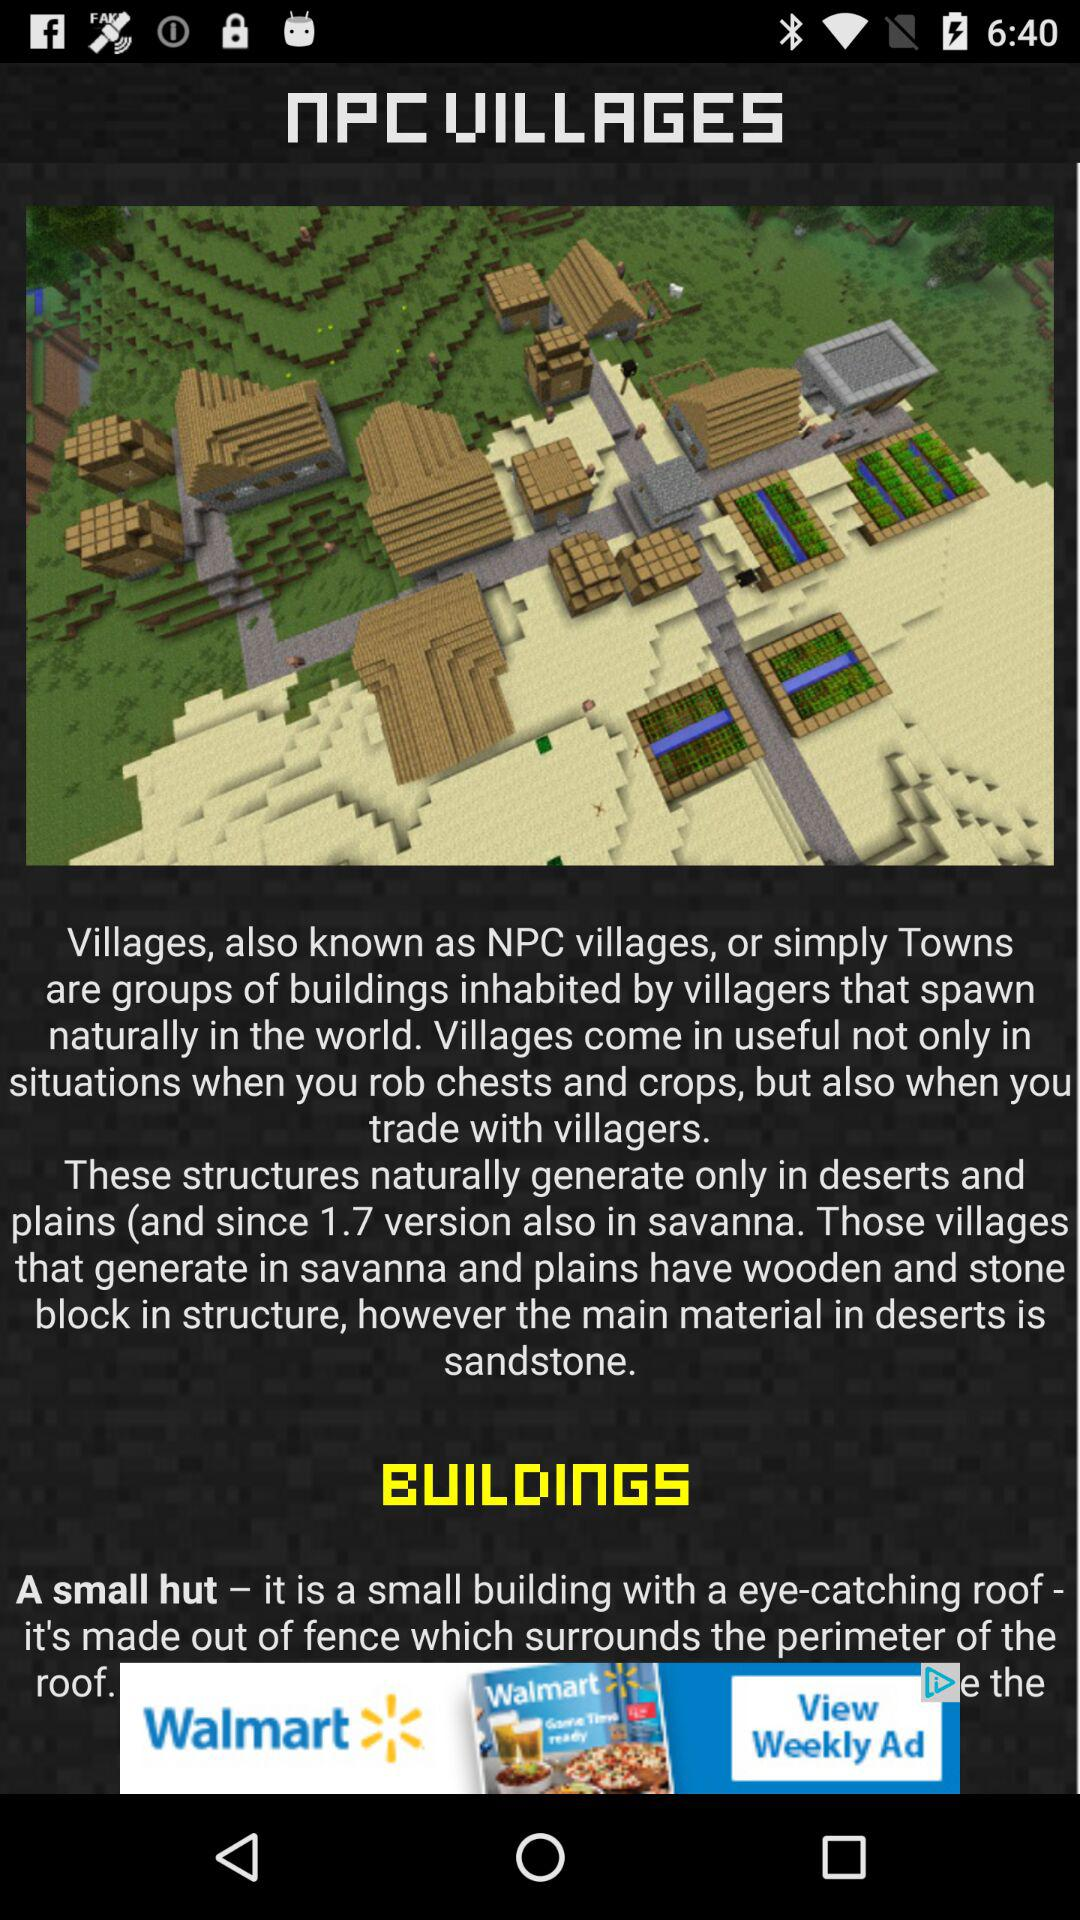Which version is available in savanna?
When the provided information is insufficient, respond with <no answer>. <no answer> 